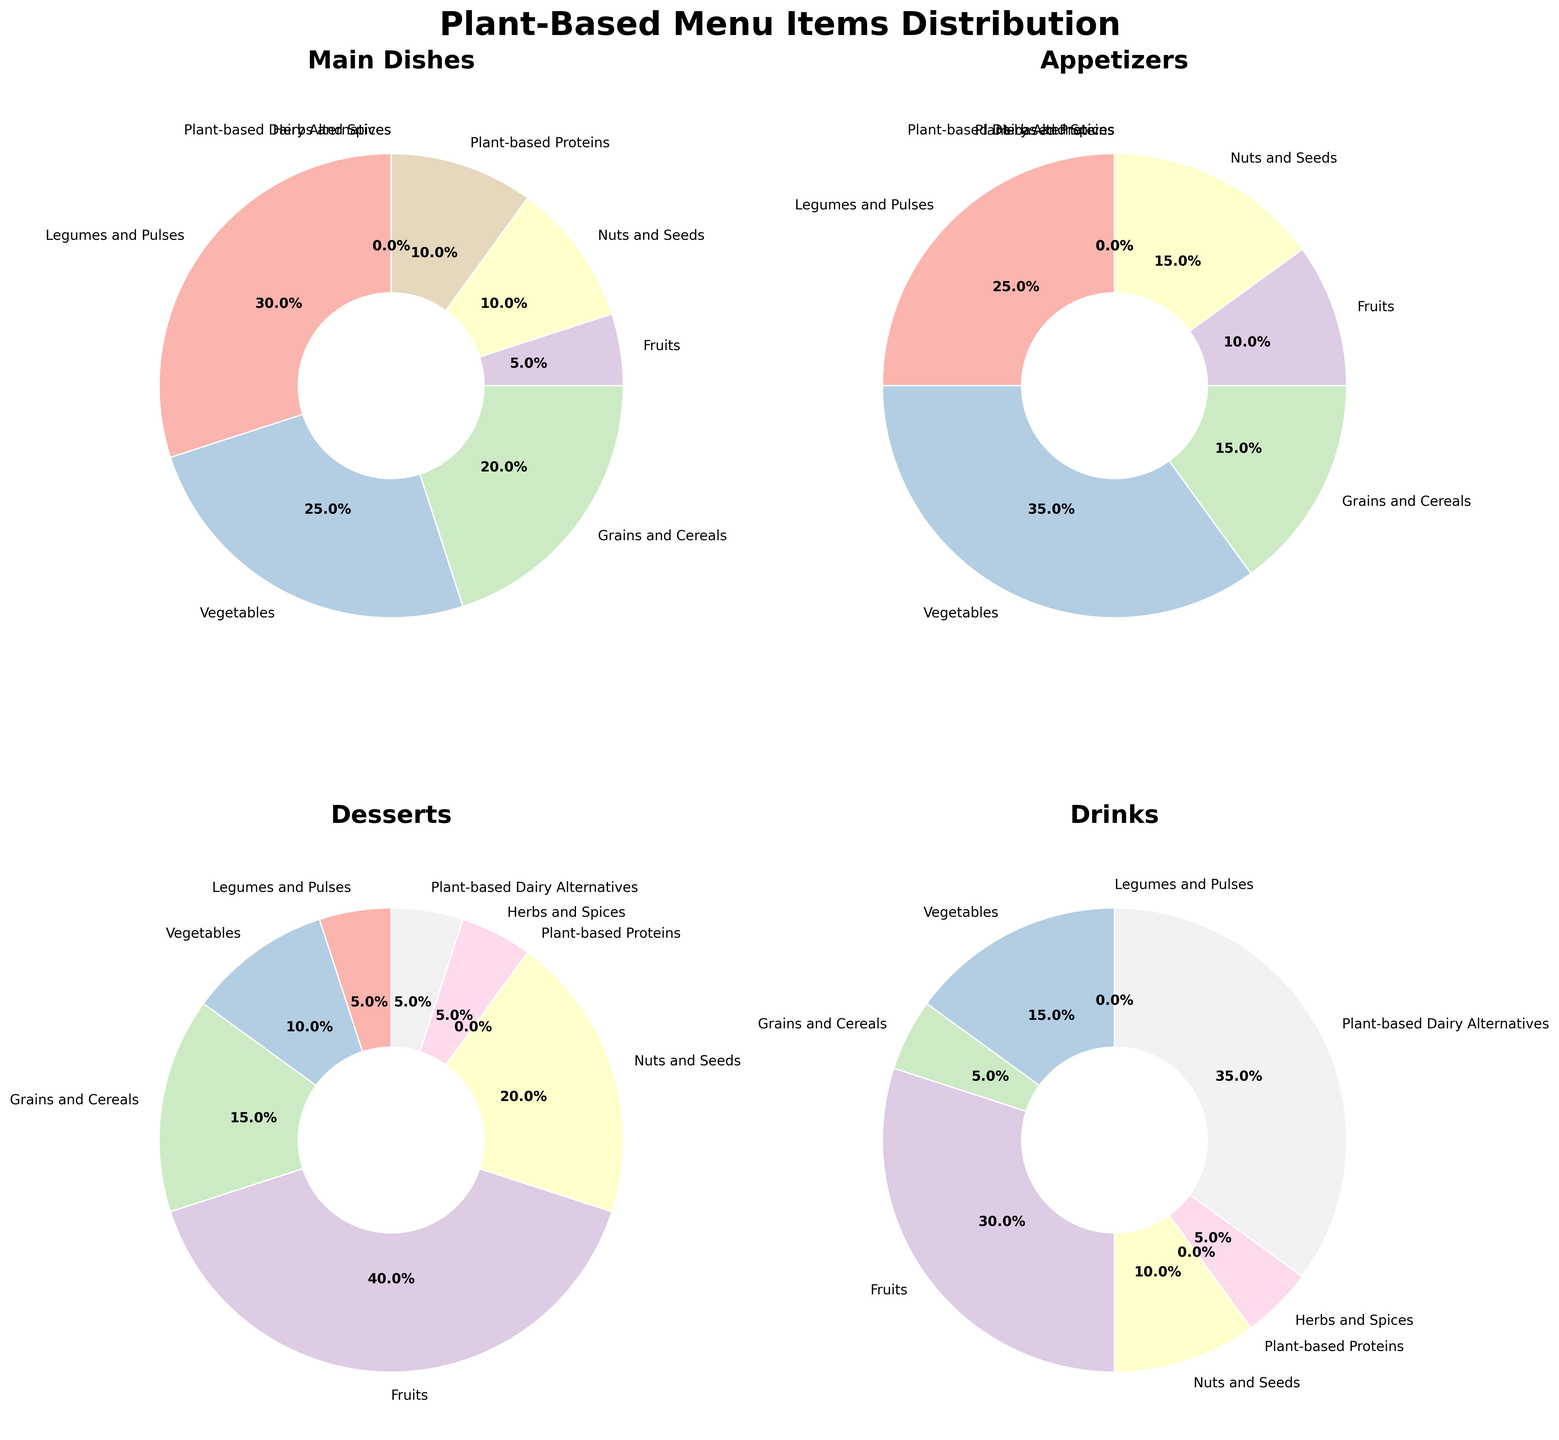What's the category with the highest percentage in the Desserts section? Looking at the Desserts pie chart, the segment labeled "Fruits" is the largest with a value of 40%.
Answer: Fruits Compare the percentage of Vegetables in Main Dishes and Appetizers. Which one is higher? In the Main Dishes pie chart, Vegetables occupy 25%, while in the Appetizers pie chart, they occupy 35%. Thus, Appetizers have a higher percentage for Vegetables.
Answer: Appetizers What's the combined percentage of Nuts and Seeds across all four sections? Add the percentages of Nuts and Seeds from each section: Main Dishes (10) + Appetizers (15) + Desserts (20) + Drinks (10). The total is 10 + 15 + 20 + 10 = 55%.
Answer: 55% In which section does Plant-based Dairy Alternatives contribute the most? Looking at the different pie charts, Plant-based Dairy Alternatives contribute 35% in the Drinks section, which is the highest among all sections.
Answer: Drinks What is the difference in the percentage of Legumes and Pulses and Grains and Cereals in Main Dishes? In the Main Dishes pie chart, Legumes and Pulses occupy 30%, and Grains and Cereals occupy 20%. The difference is 30% - 20% = 10%.
Answer: 10% Which two categories jointly make up 50% of the Appetizers section? In the Appetizers pie chart, Vegetables have 35% and Legumes and Pulses have 25%. Together, they make up 35% + 25% = 60%, so the correct combination is actually not present for exactly 50%. The next combination would be Legumes and Pulses (25%) and Grains and Cereals (15%) which sum to 40% and not 50%. Recalculate and find there is no exact two category combination making 50%.
Answer: None If you were to add the percentages of Fruits and Vegetables in Drinks, what would it be? In the Drinks section, Fruits have 30% and Vegetables have 15%. Adding them together: 30 + 15 = 45%
Answer: 45% How does the percentage of Nuts and Seeds in Desserts compare visually to Herbs and Spices in the same section? In the Desserts section, Nuts and Seeds occupy a larger segment of 20% compared to Herbs and Spices, which occupy a smaller segment of 5%.
Answer: Nuts and Seeds are higher What is the combined percentage of Plant-based Proteins and Herbs and Spices in Main Dishes? In the Main Dishes pie chart, Plant-based Proteins contribute 10% and Herbs and Spices contribute 0%. Adding these, 10% + 0% = 10%.
Answer: 10% Is there any category that appears in all four sections? By reviewing each section's pie chart, we see that no category has a non-zero percentage in all four sections.
Answer: No 